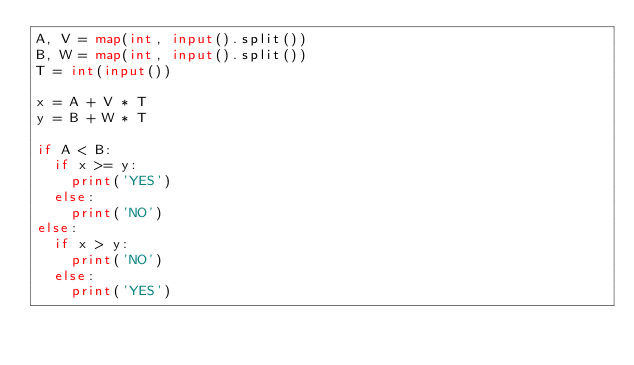Convert code to text. <code><loc_0><loc_0><loc_500><loc_500><_Python_>A, V = map(int, input().split())
B, W = map(int, input().split())
T = int(input())

x = A + V * T
y = B + W * T

if A < B:
  if x >= y:
    print('YES')
  else:
    print('NO')
else:
  if x > y:
    print('NO')
  else:
    print('YES')
</code> 